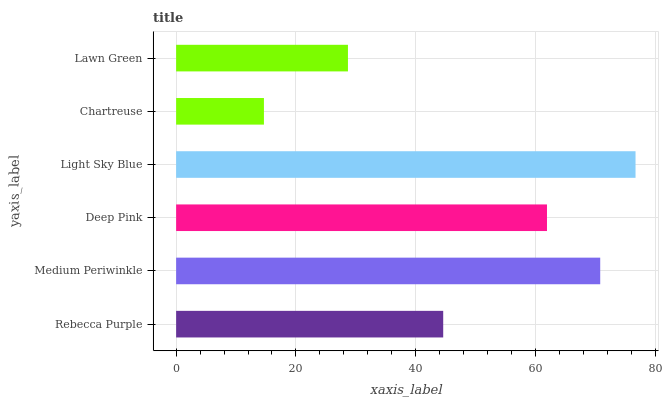Is Chartreuse the minimum?
Answer yes or no. Yes. Is Light Sky Blue the maximum?
Answer yes or no. Yes. Is Medium Periwinkle the minimum?
Answer yes or no. No. Is Medium Periwinkle the maximum?
Answer yes or no. No. Is Medium Periwinkle greater than Rebecca Purple?
Answer yes or no. Yes. Is Rebecca Purple less than Medium Periwinkle?
Answer yes or no. Yes. Is Rebecca Purple greater than Medium Periwinkle?
Answer yes or no. No. Is Medium Periwinkle less than Rebecca Purple?
Answer yes or no. No. Is Deep Pink the high median?
Answer yes or no. Yes. Is Rebecca Purple the low median?
Answer yes or no. Yes. Is Medium Periwinkle the high median?
Answer yes or no. No. Is Deep Pink the low median?
Answer yes or no. No. 